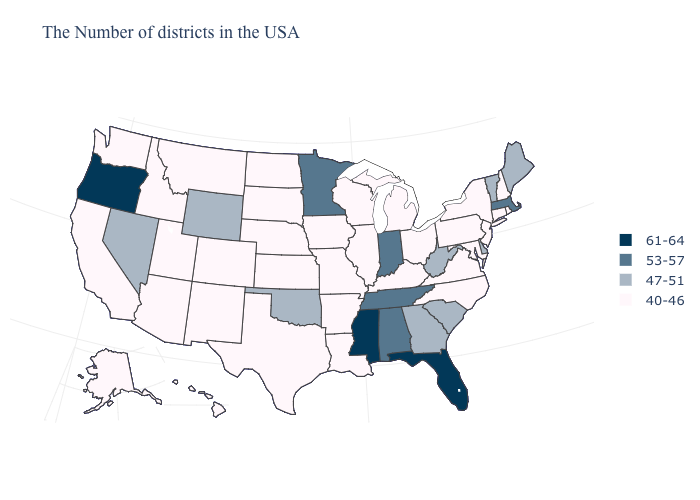What is the lowest value in the Northeast?
Keep it brief. 40-46. What is the value of Illinois?
Keep it brief. 40-46. Does the first symbol in the legend represent the smallest category?
Give a very brief answer. No. Does West Virginia have the lowest value in the USA?
Give a very brief answer. No. Which states have the lowest value in the West?
Write a very short answer. Colorado, New Mexico, Utah, Montana, Arizona, Idaho, California, Washington, Alaska, Hawaii. Name the states that have a value in the range 47-51?
Concise answer only. Maine, Vermont, Delaware, South Carolina, West Virginia, Georgia, Oklahoma, Wyoming, Nevada. What is the highest value in states that border South Dakota?
Keep it brief. 53-57. Name the states that have a value in the range 61-64?
Concise answer only. Florida, Mississippi, Oregon. Does the map have missing data?
Answer briefly. No. Among the states that border New Jersey , does Pennsylvania have the lowest value?
Answer briefly. Yes. Does Florida have the highest value in the South?
Be succinct. Yes. Name the states that have a value in the range 40-46?
Short answer required. Rhode Island, New Hampshire, Connecticut, New York, New Jersey, Maryland, Pennsylvania, Virginia, North Carolina, Ohio, Michigan, Kentucky, Wisconsin, Illinois, Louisiana, Missouri, Arkansas, Iowa, Kansas, Nebraska, Texas, South Dakota, North Dakota, Colorado, New Mexico, Utah, Montana, Arizona, Idaho, California, Washington, Alaska, Hawaii. Does Ohio have the highest value in the MidWest?
Short answer required. No. Does Virginia have a lower value than Massachusetts?
Concise answer only. Yes. What is the highest value in the South ?
Concise answer only. 61-64. 